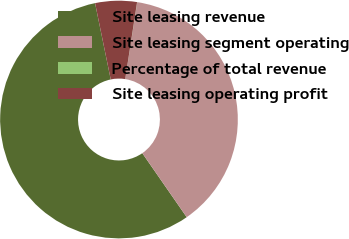Convert chart to OTSL. <chart><loc_0><loc_0><loc_500><loc_500><pie_chart><fcel>Site leasing revenue<fcel>Site leasing segment operating<fcel>Percentage of total revenue<fcel>Site leasing operating profit<nl><fcel>56.42%<fcel>37.89%<fcel>0.02%<fcel>5.66%<nl></chart> 